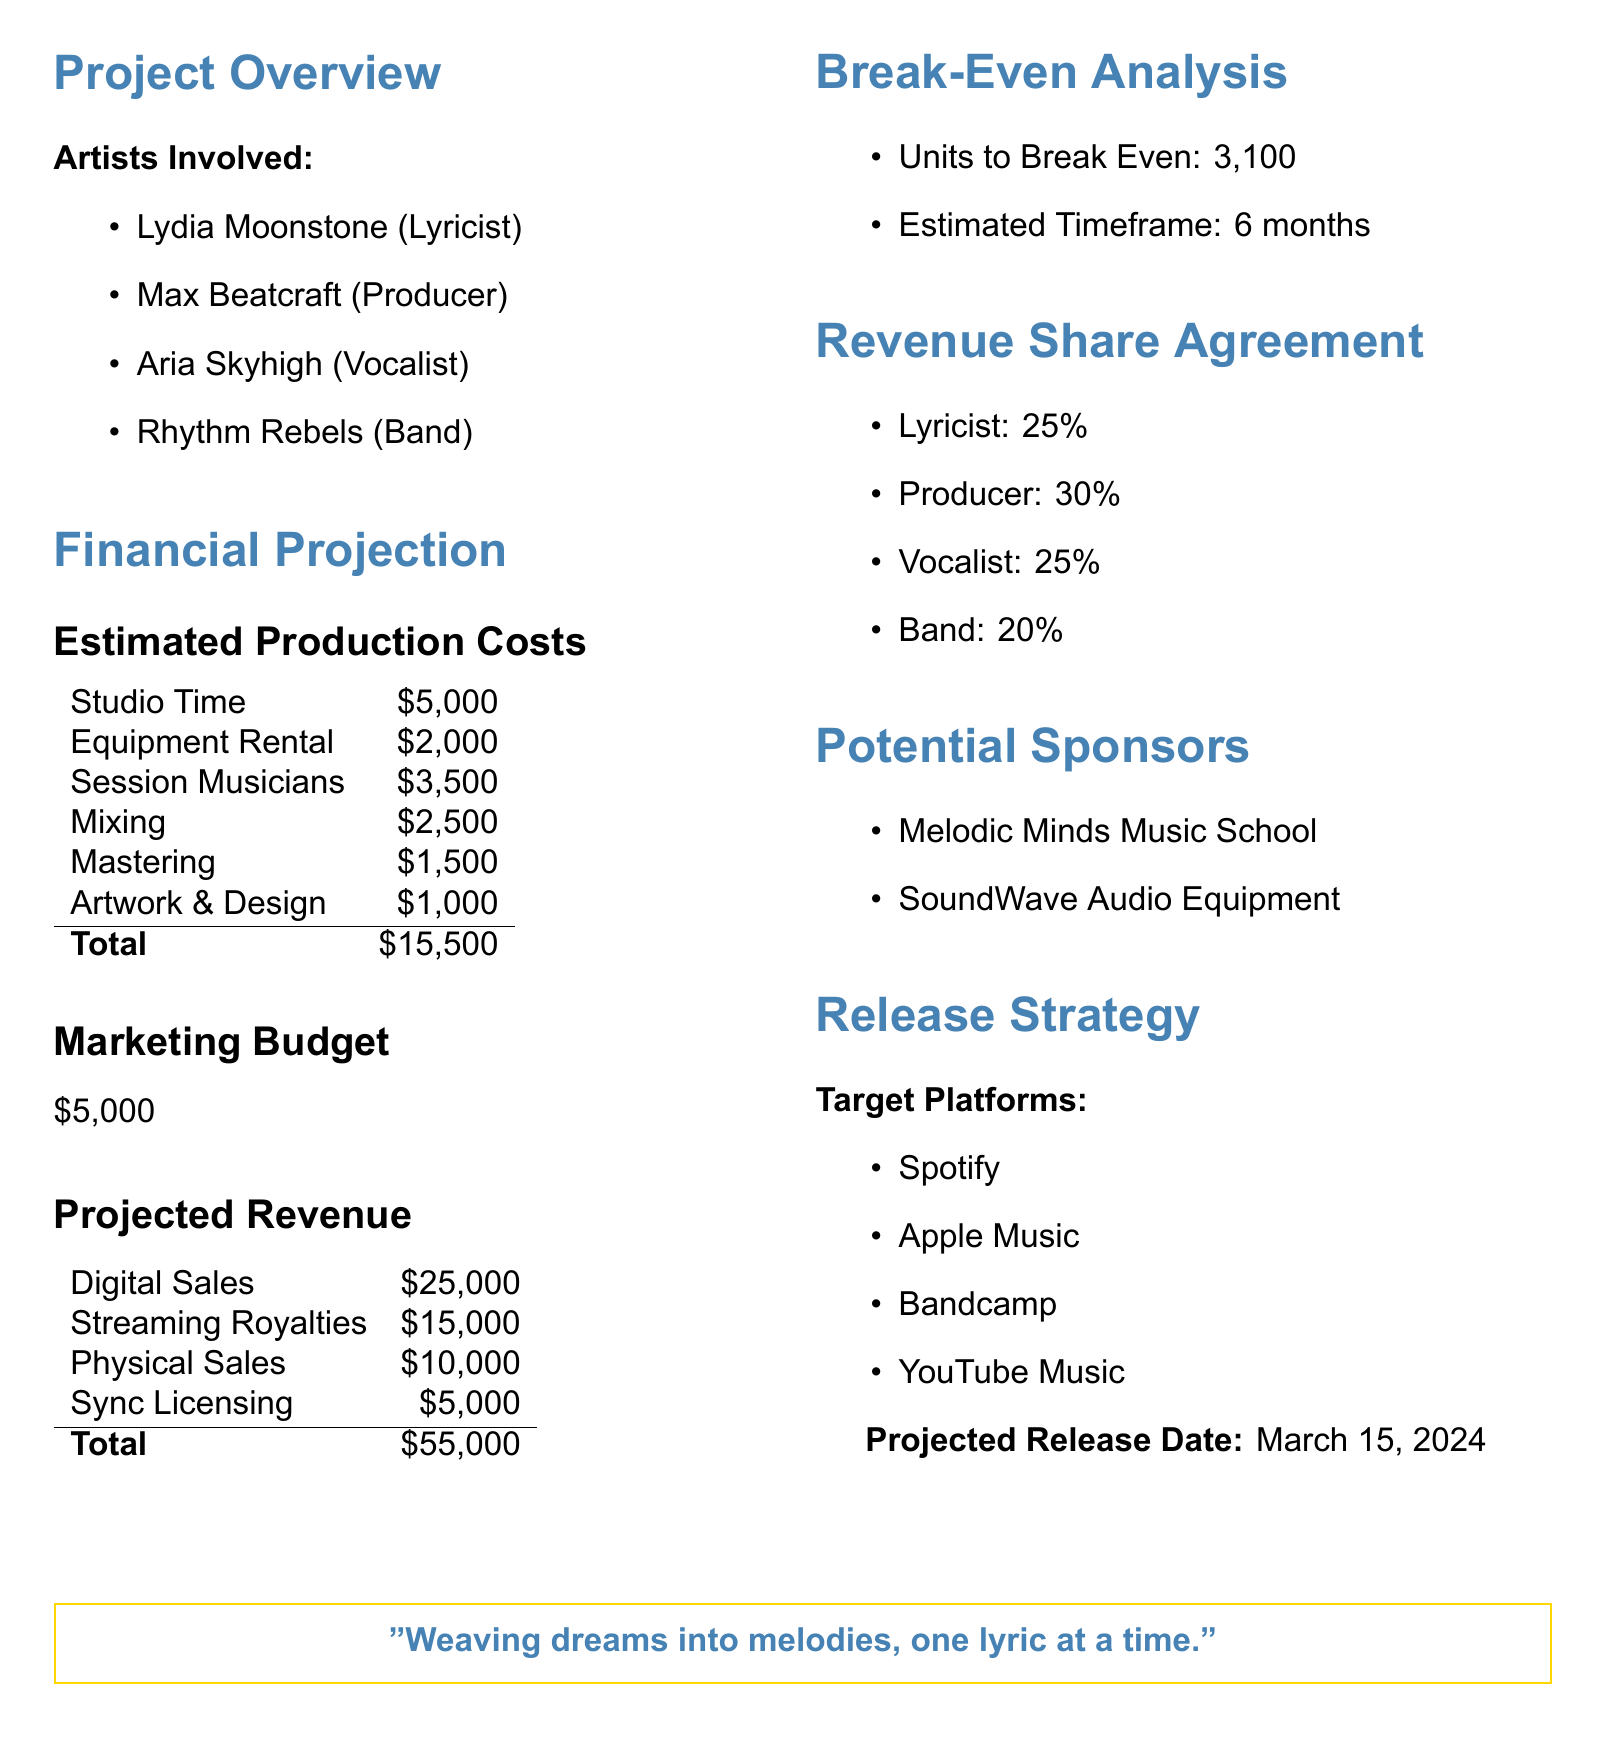What is the total production cost? The total production cost is listed in the document, which sums up all estimated production expenses.
Answer: $15,500 Who is the producer involved in the project? The document lists the artists involved, including the specific role of each artist.
Answer: Max Beatcraft What is the projected release date of the album? The release strategy section of the document specifies the anticipated date for the album launch.
Answer: March 15, 2024 How many units need to be sold to break even? The break-even analysis provides the specific number of units required to cover all production and marketing costs.
Answer: 3,100 What percentage of revenue does the vocalist receive? The revenue share agreement outlines the percentage allocations for each artist involved.
Answer: 25% What is the total projected revenue from digital sales? The projected revenue section mentions specific income sources, including digital sales, which is one of those sources.
Answer: $25,000 Which marketing budget is allocated for the project? The financial projection summarizes the marketing budget allocated for promotional efforts for the album.
Answer: $5,000 Name one potential sponsor for the album. The document lists potential sponsors that could support the album project financially.
Answer: Melodic Minds Music School 